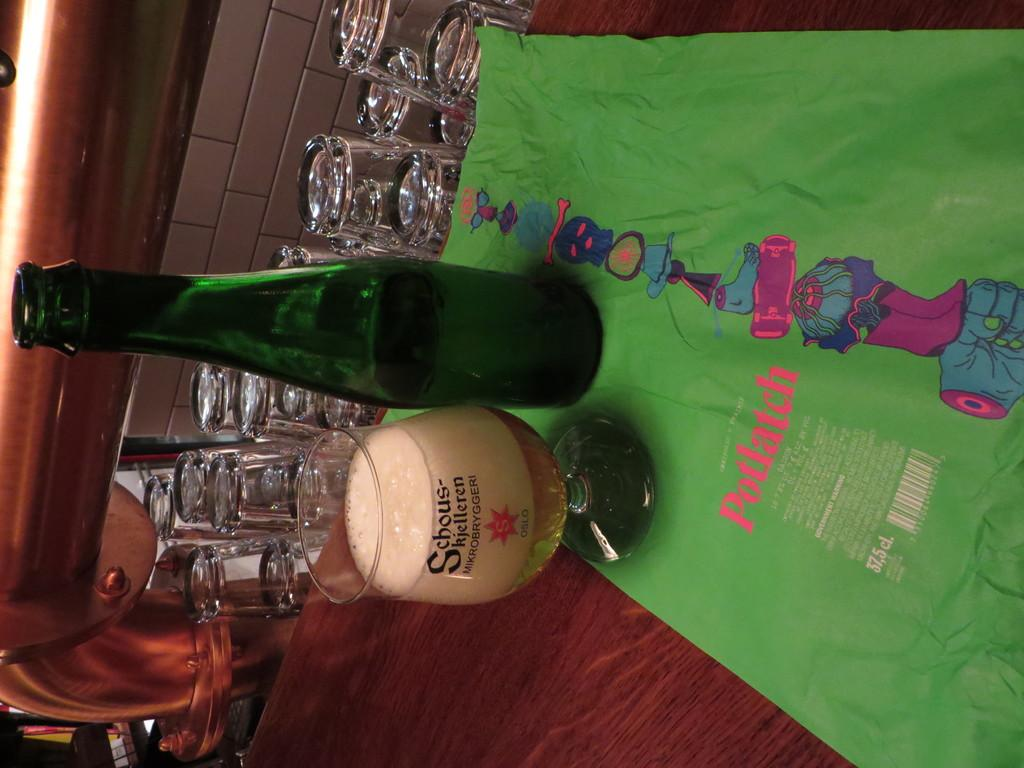<image>
Provide a brief description of the given image. A Potlach written in red that is on a green cloth 